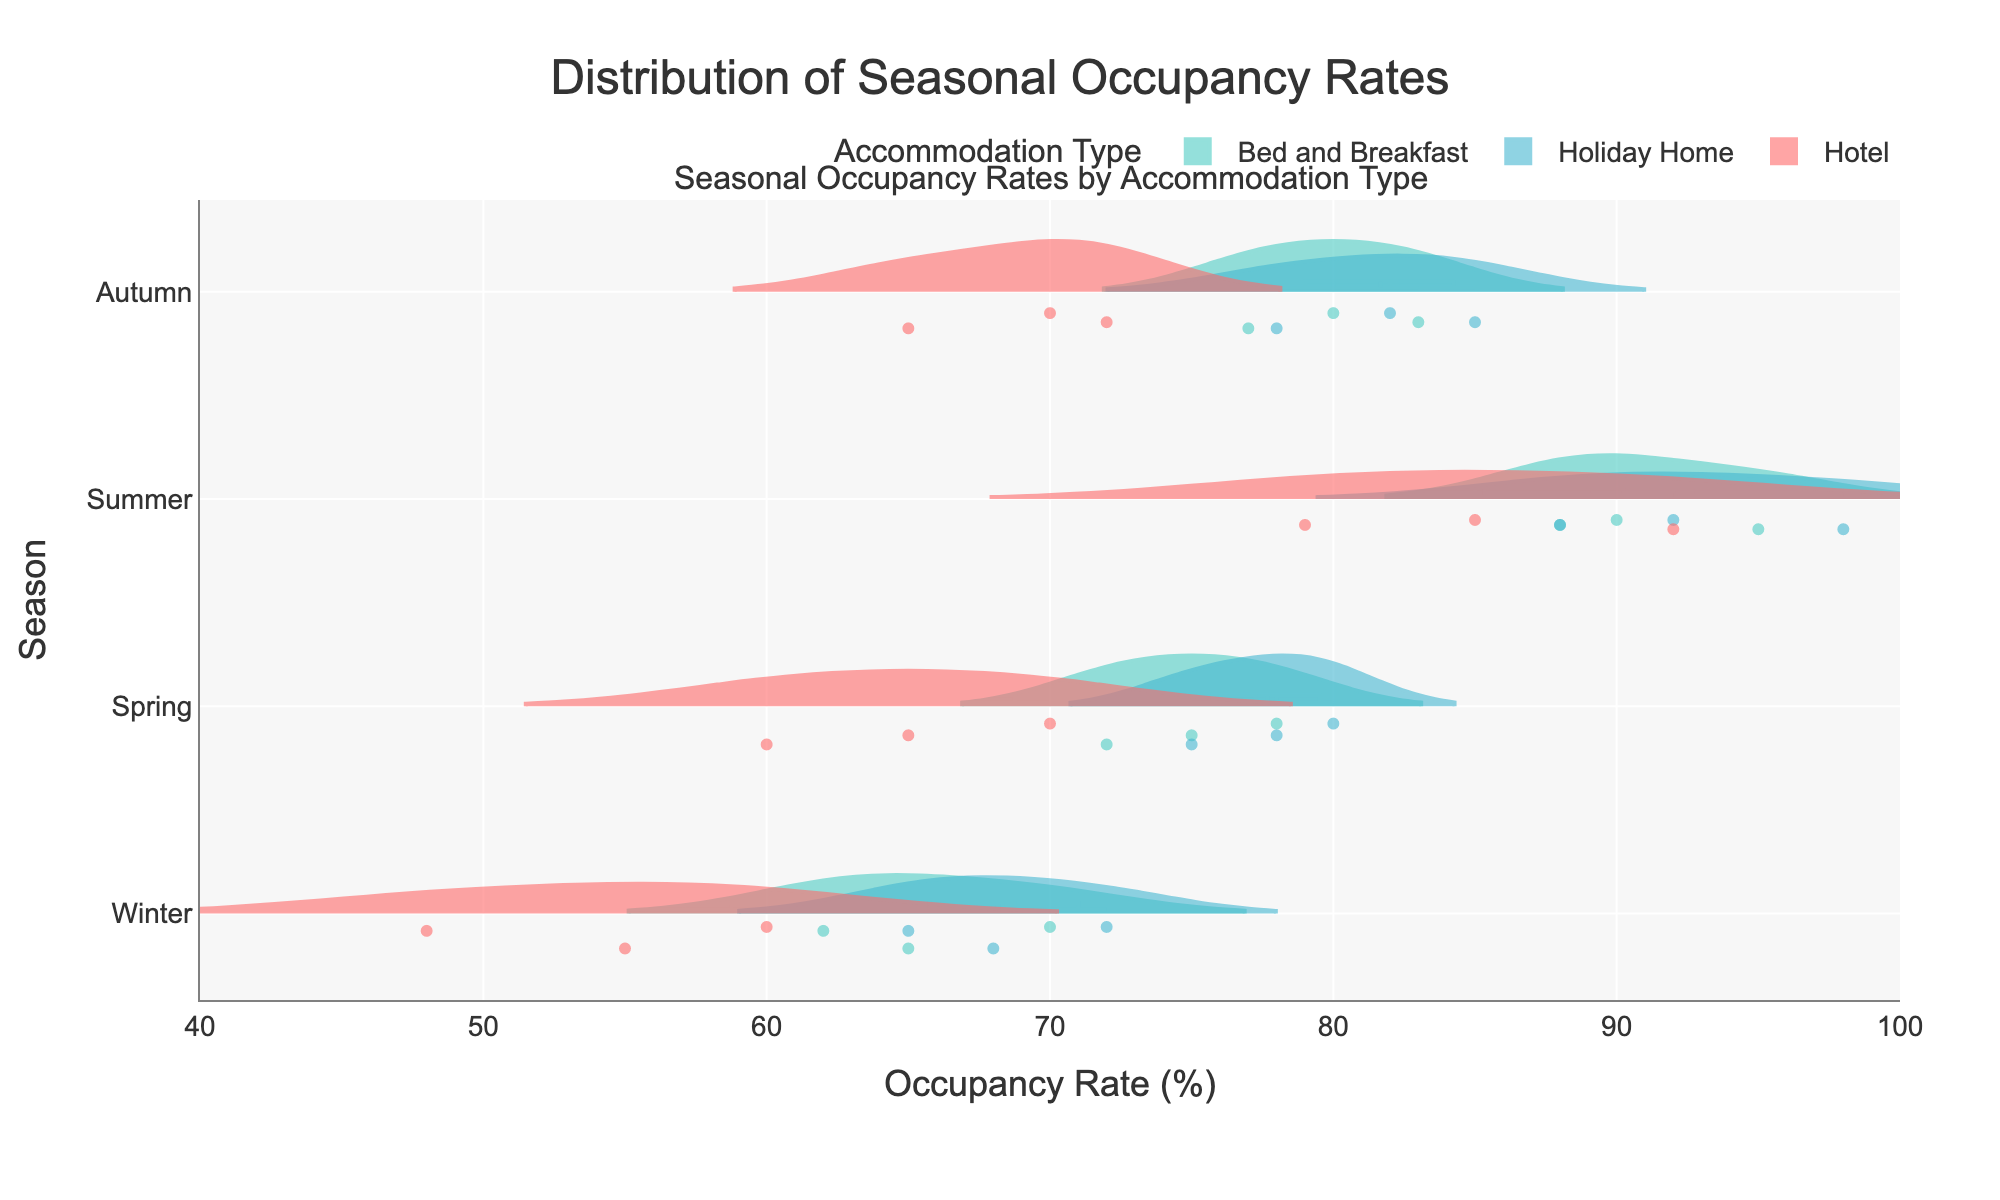What is the highest occupancy rate recorded in Summer for any accommodation type? From the chart, identify the maximum value for occupancy rates under the 'Summer' category.
Answer: 98 Are the occupancy rates for Hotels generally higher in Summer or Spring? Compare the distribution and median values of occupancy rates for Hotels in Summer and Spring. The violins for Summer should be broader and centered at a higher range compared to Spring.
Answer: Summer Which season has the widest range of occupancy rates for Bed and Breakfast? Assess the spread of the distributions for Bed and Breakfast across seasons. The season with the largest spread or the longest distribution width indicates the widest range.
Answer: Winter How does the median occupancy rate of Holiday Homes in Autumn compare to that in Spring? Observe the median lines within the violin charts for Holiday Homes in both Autumn and Spring. Compare their positions on the x-axis.
Answer: Autumn What can you say about the overall occupancy rate patterns for Holiday Homes across all seasons? Summarize where the bulk of the data is located and the spread for each season for Holiday Homes. Winter and Autumn distributions are moderately wide, Spring is slightly narrower, and Summer is broad and shifted to higher values. This indicates varying levels of occupancy through different times of the year.
Answer: Highest in Summer, varying in other seasons Does any season show a similar occupancy rate distribution for Hotels and Bed and Breakfasts? Compare the shapes and ranges of the violins for Hotels and Bed and Breakfasts within each season. Identify which season shows the most resemblance in patterns and distributions.
Answer: Spring Which season has the highest median occupancy rate overall, regardless of accommodation type? Observe the median lines of all distributions within each season. The season with the highest combined median value across different accommodation types is determined.
Answer: Summer In which two seasons do Holiday Homes have almost identical occupancy rates? Compare the violin charts for Holiday Homes across all seasons to see if there are any pairs of seasons with overlapping or very similar distributions.
Answer: Spring and Autumn 